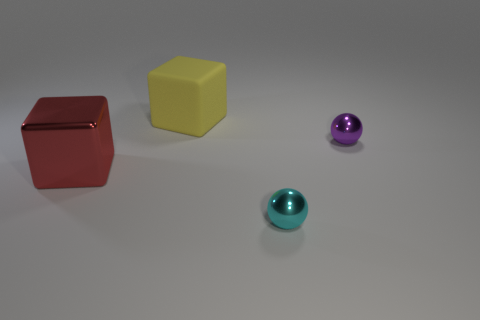Add 3 large yellow objects. How many objects exist? 7 Subtract 0 yellow spheres. How many objects are left? 4 Subtract all tiny cyan metallic spheres. Subtract all red objects. How many objects are left? 2 Add 4 small cyan metallic things. How many small cyan metallic things are left? 5 Add 1 red blocks. How many red blocks exist? 2 